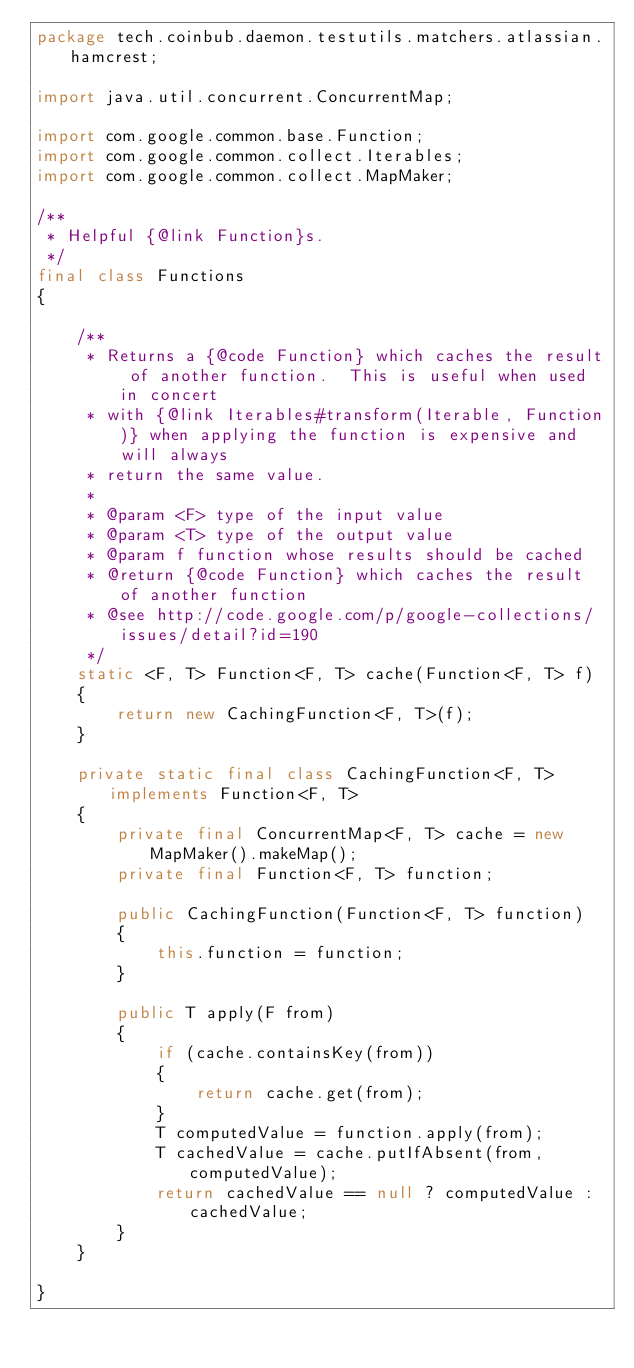<code> <loc_0><loc_0><loc_500><loc_500><_Java_>package tech.coinbub.daemon.testutils.matchers.atlassian.hamcrest;

import java.util.concurrent.ConcurrentMap;

import com.google.common.base.Function;
import com.google.common.collect.Iterables;
import com.google.common.collect.MapMaker;

/**
 * Helpful {@link Function}s.
 */
final class Functions
{

    /**
     * Returns a {@code Function} which caches the result of another function.  This is useful when used in concert
     * with {@link Iterables#transform(Iterable, Function)} when applying the function is expensive and will always
     * return the same value.
     * 
     * @param <F> type of the input value
     * @param <T> type of the output value
     * @param f function whose results should be cached
     * @return {@code Function} which caches the result of another function
     * @see http://code.google.com/p/google-collections/issues/detail?id=190
     */
    static <F, T> Function<F, T> cache(Function<F, T> f)
    {
        return new CachingFunction<F, T>(f);
    }

    private static final class CachingFunction<F, T> implements Function<F, T>
    {
        private final ConcurrentMap<F, T> cache = new MapMaker().makeMap();
        private final Function<F, T> function;
        
        public CachingFunction(Function<F, T> function)
        {
            this.function = function;
        }

        public T apply(F from)
        {
            if (cache.containsKey(from))
            {
                return cache.get(from);
            }
            T computedValue = function.apply(from);
            T cachedValue = cache.putIfAbsent(from, computedValue);
            return cachedValue == null ? computedValue : cachedValue;
        }
    }

}
</code> 